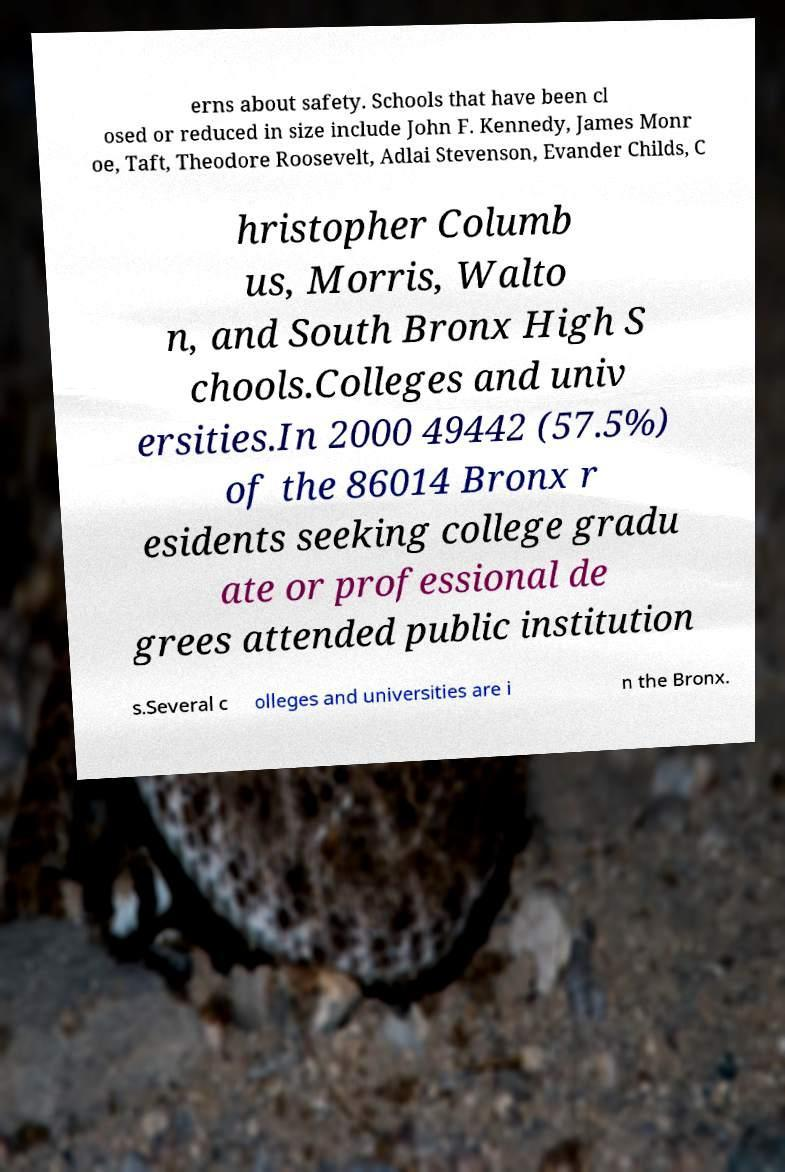Could you assist in decoding the text presented in this image and type it out clearly? erns about safety. Schools that have been cl osed or reduced in size include John F. Kennedy, James Monr oe, Taft, Theodore Roosevelt, Adlai Stevenson, Evander Childs, C hristopher Columb us, Morris, Walto n, and South Bronx High S chools.Colleges and univ ersities.In 2000 49442 (57.5%) of the 86014 Bronx r esidents seeking college gradu ate or professional de grees attended public institution s.Several c olleges and universities are i n the Bronx. 